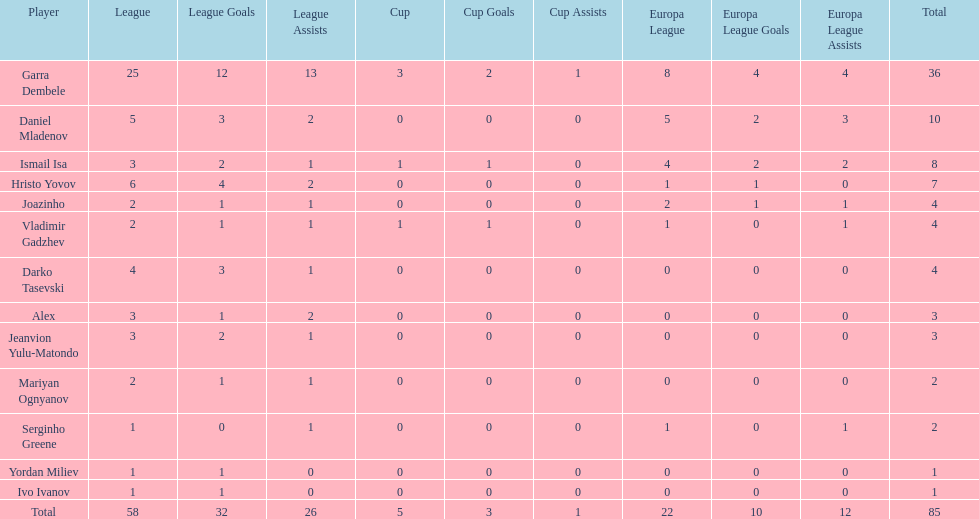What is the difference between vladimir gadzhev and yordan miliev's scores? 3. 